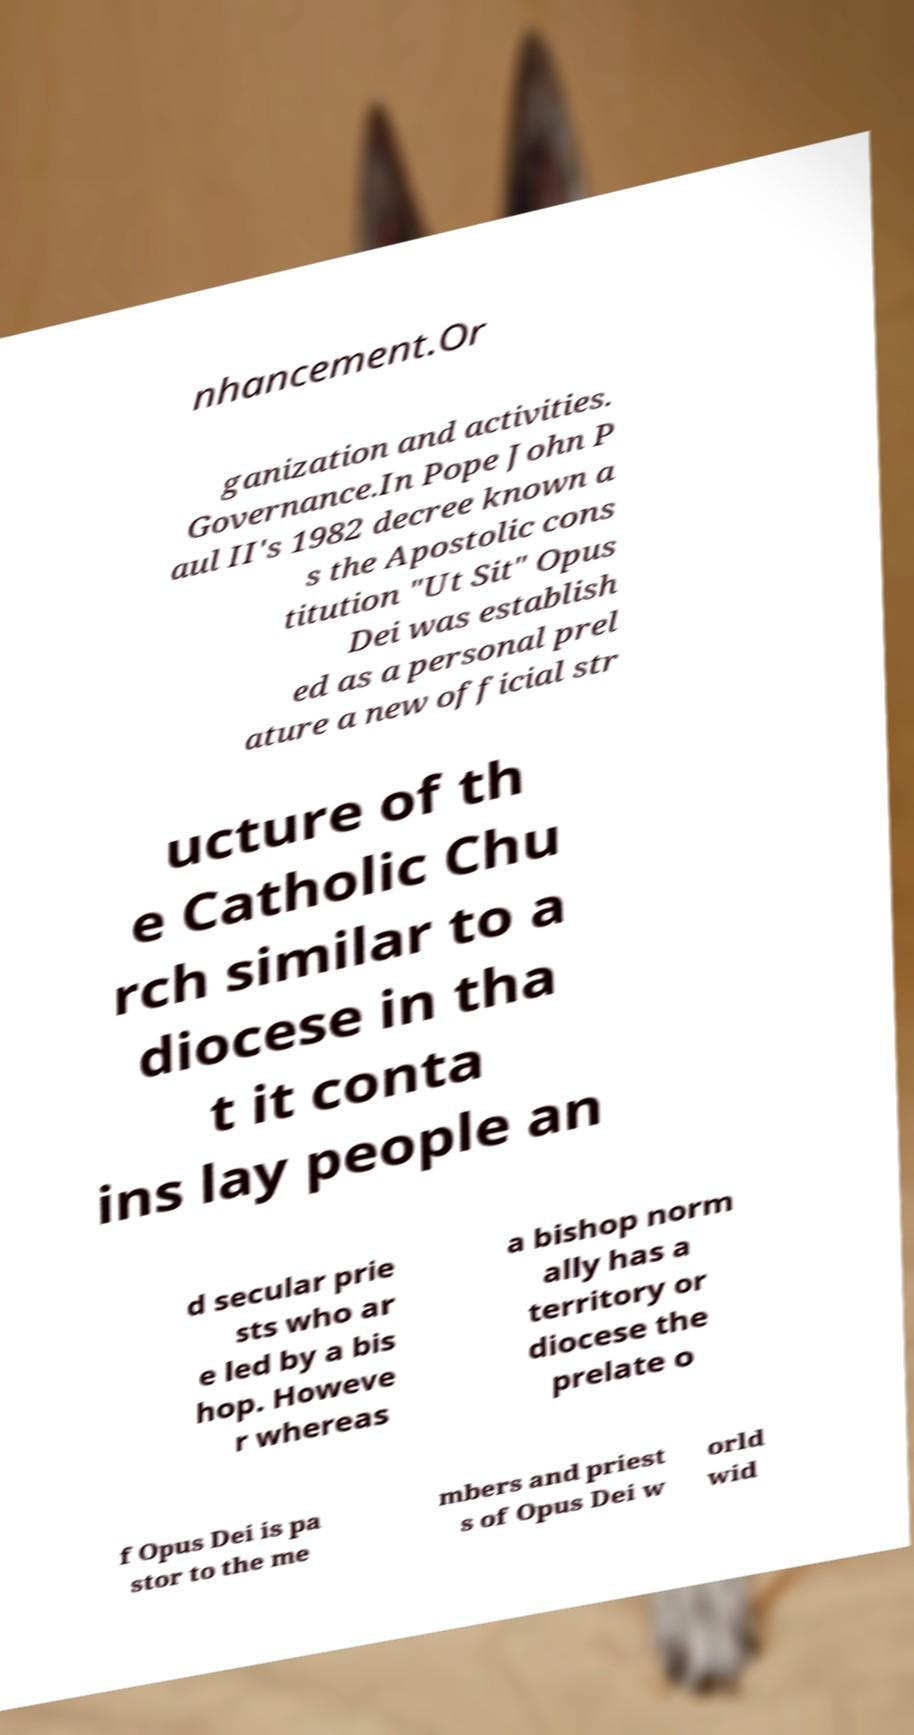There's text embedded in this image that I need extracted. Can you transcribe it verbatim? nhancement.Or ganization and activities. Governance.In Pope John P aul II's 1982 decree known a s the Apostolic cons titution "Ut Sit" Opus Dei was establish ed as a personal prel ature a new official str ucture of th e Catholic Chu rch similar to a diocese in tha t it conta ins lay people an d secular prie sts who ar e led by a bis hop. Howeve r whereas a bishop norm ally has a territory or diocese the prelate o f Opus Dei is pa stor to the me mbers and priest s of Opus Dei w orld wid 